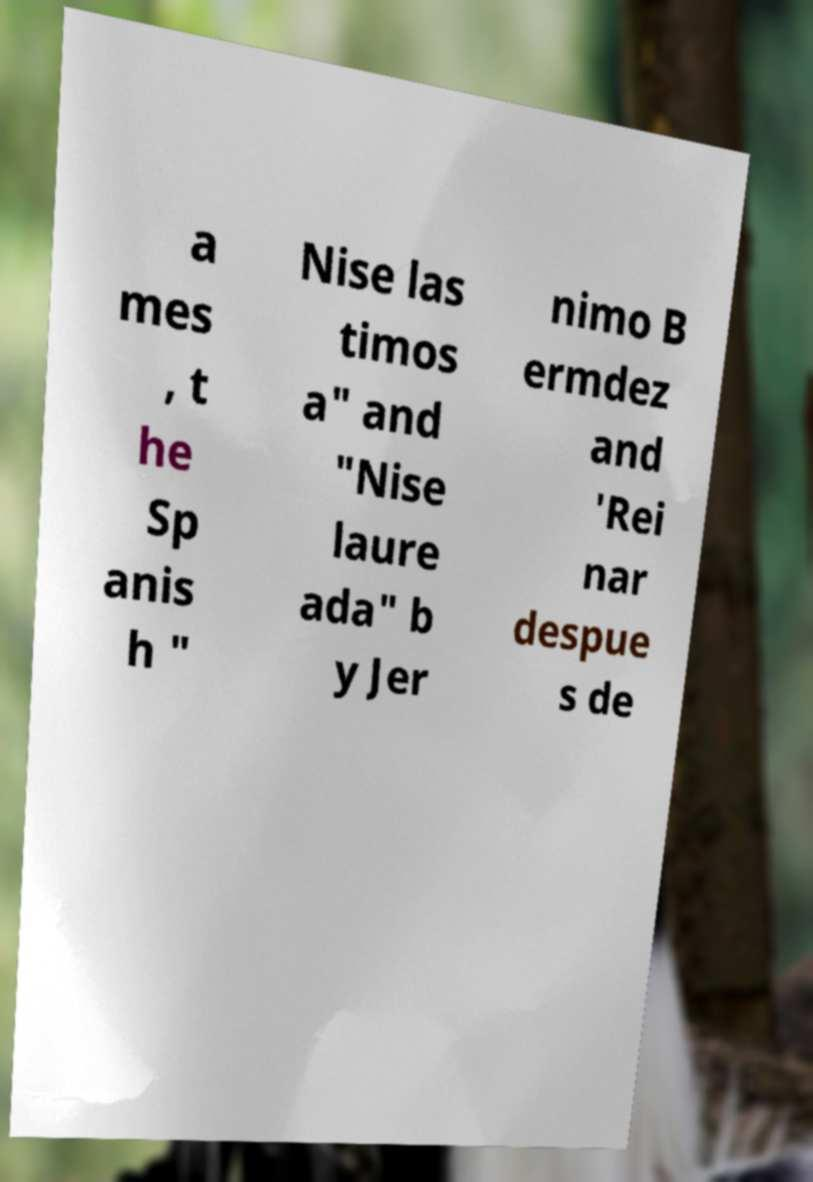I need the written content from this picture converted into text. Can you do that? a mes , t he Sp anis h " Nise las timos a" and "Nise laure ada" b y Jer nimo B ermdez and 'Rei nar despue s de 